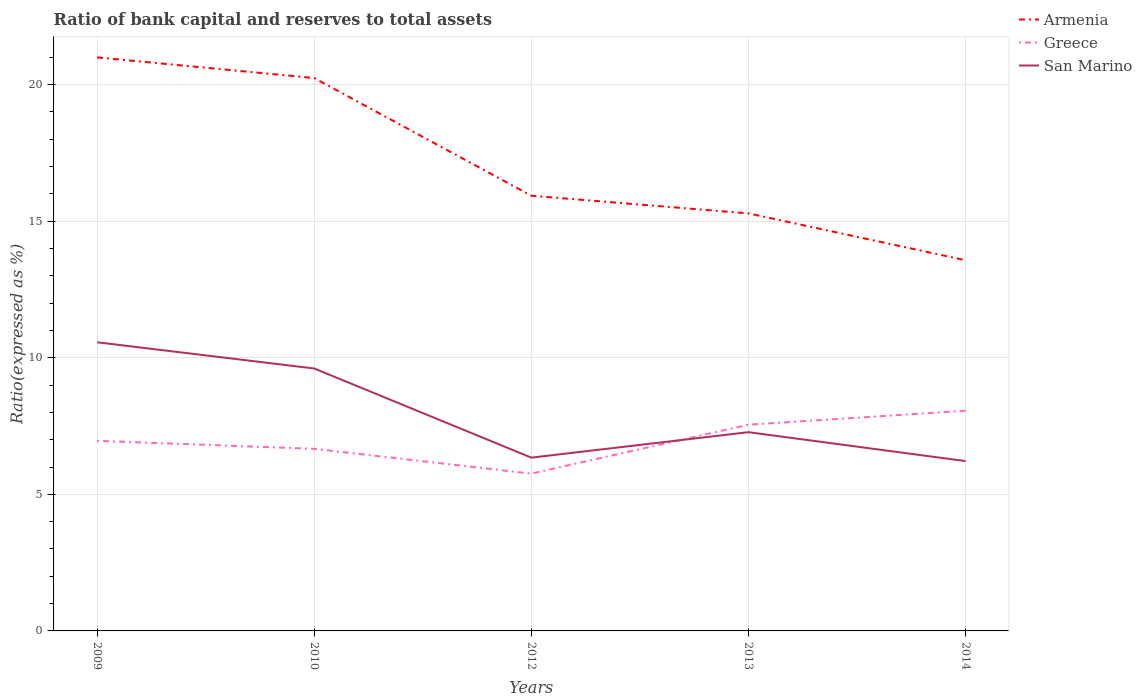Does the line corresponding to San Marino intersect with the line corresponding to Greece?
Keep it short and to the point. Yes. Across all years, what is the maximum ratio of bank capital and reserves to total assets in Armenia?
Keep it short and to the point. 13.57. In which year was the ratio of bank capital and reserves to total assets in Greece maximum?
Offer a very short reply. 2012. What is the total ratio of bank capital and reserves to total assets in San Marino in the graph?
Your answer should be very brief. 4.22. What is the difference between the highest and the second highest ratio of bank capital and reserves to total assets in Greece?
Offer a terse response. 2.3. How many lines are there?
Make the answer very short. 3. What is the difference between two consecutive major ticks on the Y-axis?
Offer a very short reply. 5. Does the graph contain any zero values?
Provide a succinct answer. No. Does the graph contain grids?
Your answer should be very brief. Yes. Where does the legend appear in the graph?
Your answer should be very brief. Top right. How many legend labels are there?
Your response must be concise. 3. What is the title of the graph?
Ensure brevity in your answer.  Ratio of bank capital and reserves to total assets. What is the label or title of the Y-axis?
Your answer should be very brief. Ratio(expressed as %). What is the Ratio(expressed as %) in Armenia in 2009?
Ensure brevity in your answer.  20.99. What is the Ratio(expressed as %) of Greece in 2009?
Your answer should be compact. 6.96. What is the Ratio(expressed as %) of San Marino in 2009?
Your answer should be very brief. 10.57. What is the Ratio(expressed as %) in Armenia in 2010?
Offer a terse response. 20.24. What is the Ratio(expressed as %) in Greece in 2010?
Offer a terse response. 6.66. What is the Ratio(expressed as %) in San Marino in 2010?
Your answer should be very brief. 9.61. What is the Ratio(expressed as %) in Armenia in 2012?
Keep it short and to the point. 15.93. What is the Ratio(expressed as %) in Greece in 2012?
Your answer should be very brief. 5.76. What is the Ratio(expressed as %) of San Marino in 2012?
Your answer should be compact. 6.34. What is the Ratio(expressed as %) in Armenia in 2013?
Offer a terse response. 15.28. What is the Ratio(expressed as %) of Greece in 2013?
Provide a succinct answer. 7.55. What is the Ratio(expressed as %) in San Marino in 2013?
Give a very brief answer. 7.28. What is the Ratio(expressed as %) in Armenia in 2014?
Offer a very short reply. 13.57. What is the Ratio(expressed as %) of Greece in 2014?
Offer a very short reply. 8.06. What is the Ratio(expressed as %) in San Marino in 2014?
Provide a short and direct response. 6.22. Across all years, what is the maximum Ratio(expressed as %) of Armenia?
Make the answer very short. 20.99. Across all years, what is the maximum Ratio(expressed as %) in Greece?
Your response must be concise. 8.06. Across all years, what is the maximum Ratio(expressed as %) of San Marino?
Provide a succinct answer. 10.57. Across all years, what is the minimum Ratio(expressed as %) of Armenia?
Provide a succinct answer. 13.57. Across all years, what is the minimum Ratio(expressed as %) of Greece?
Give a very brief answer. 5.76. Across all years, what is the minimum Ratio(expressed as %) in San Marino?
Provide a short and direct response. 6.22. What is the total Ratio(expressed as %) of Armenia in the graph?
Provide a short and direct response. 86.02. What is the total Ratio(expressed as %) of Greece in the graph?
Ensure brevity in your answer.  34.99. What is the total Ratio(expressed as %) in San Marino in the graph?
Provide a succinct answer. 40.01. What is the difference between the Ratio(expressed as %) of Armenia in 2009 and that in 2010?
Offer a very short reply. 0.76. What is the difference between the Ratio(expressed as %) of Greece in 2009 and that in 2010?
Provide a succinct answer. 0.29. What is the difference between the Ratio(expressed as %) in San Marino in 2009 and that in 2010?
Offer a terse response. 0.96. What is the difference between the Ratio(expressed as %) in Armenia in 2009 and that in 2012?
Your answer should be very brief. 5.06. What is the difference between the Ratio(expressed as %) in Greece in 2009 and that in 2012?
Your answer should be very brief. 1.2. What is the difference between the Ratio(expressed as %) of San Marino in 2009 and that in 2012?
Keep it short and to the point. 4.22. What is the difference between the Ratio(expressed as %) of Armenia in 2009 and that in 2013?
Make the answer very short. 5.71. What is the difference between the Ratio(expressed as %) in Greece in 2009 and that in 2013?
Provide a short and direct response. -0.59. What is the difference between the Ratio(expressed as %) of San Marino in 2009 and that in 2013?
Your response must be concise. 3.29. What is the difference between the Ratio(expressed as %) of Armenia in 2009 and that in 2014?
Offer a terse response. 7.43. What is the difference between the Ratio(expressed as %) of Greece in 2009 and that in 2014?
Ensure brevity in your answer.  -1.1. What is the difference between the Ratio(expressed as %) in San Marino in 2009 and that in 2014?
Your answer should be compact. 4.35. What is the difference between the Ratio(expressed as %) in Armenia in 2010 and that in 2012?
Your answer should be compact. 4.31. What is the difference between the Ratio(expressed as %) of Greece in 2010 and that in 2012?
Ensure brevity in your answer.  0.91. What is the difference between the Ratio(expressed as %) of San Marino in 2010 and that in 2012?
Provide a succinct answer. 3.26. What is the difference between the Ratio(expressed as %) of Armenia in 2010 and that in 2013?
Offer a terse response. 4.95. What is the difference between the Ratio(expressed as %) in Greece in 2010 and that in 2013?
Give a very brief answer. -0.88. What is the difference between the Ratio(expressed as %) in San Marino in 2010 and that in 2013?
Offer a terse response. 2.33. What is the difference between the Ratio(expressed as %) of Armenia in 2010 and that in 2014?
Give a very brief answer. 6.67. What is the difference between the Ratio(expressed as %) in Greece in 2010 and that in 2014?
Ensure brevity in your answer.  -1.4. What is the difference between the Ratio(expressed as %) of San Marino in 2010 and that in 2014?
Keep it short and to the point. 3.39. What is the difference between the Ratio(expressed as %) in Armenia in 2012 and that in 2013?
Offer a very short reply. 0.65. What is the difference between the Ratio(expressed as %) in Greece in 2012 and that in 2013?
Your answer should be compact. -1.79. What is the difference between the Ratio(expressed as %) of San Marino in 2012 and that in 2013?
Offer a terse response. -0.93. What is the difference between the Ratio(expressed as %) of Armenia in 2012 and that in 2014?
Provide a short and direct response. 2.36. What is the difference between the Ratio(expressed as %) of Greece in 2012 and that in 2014?
Make the answer very short. -2.3. What is the difference between the Ratio(expressed as %) of San Marino in 2012 and that in 2014?
Provide a succinct answer. 0.13. What is the difference between the Ratio(expressed as %) of Armenia in 2013 and that in 2014?
Your answer should be compact. 1.71. What is the difference between the Ratio(expressed as %) of Greece in 2013 and that in 2014?
Your answer should be compact. -0.51. What is the difference between the Ratio(expressed as %) in San Marino in 2013 and that in 2014?
Your response must be concise. 1.06. What is the difference between the Ratio(expressed as %) in Armenia in 2009 and the Ratio(expressed as %) in Greece in 2010?
Your response must be concise. 14.33. What is the difference between the Ratio(expressed as %) of Armenia in 2009 and the Ratio(expressed as %) of San Marino in 2010?
Your answer should be very brief. 11.39. What is the difference between the Ratio(expressed as %) in Greece in 2009 and the Ratio(expressed as %) in San Marino in 2010?
Provide a succinct answer. -2.65. What is the difference between the Ratio(expressed as %) of Armenia in 2009 and the Ratio(expressed as %) of Greece in 2012?
Keep it short and to the point. 15.24. What is the difference between the Ratio(expressed as %) in Armenia in 2009 and the Ratio(expressed as %) in San Marino in 2012?
Provide a succinct answer. 14.65. What is the difference between the Ratio(expressed as %) of Greece in 2009 and the Ratio(expressed as %) of San Marino in 2012?
Give a very brief answer. 0.62. What is the difference between the Ratio(expressed as %) of Armenia in 2009 and the Ratio(expressed as %) of Greece in 2013?
Make the answer very short. 13.45. What is the difference between the Ratio(expressed as %) of Armenia in 2009 and the Ratio(expressed as %) of San Marino in 2013?
Ensure brevity in your answer.  13.72. What is the difference between the Ratio(expressed as %) of Greece in 2009 and the Ratio(expressed as %) of San Marino in 2013?
Provide a succinct answer. -0.32. What is the difference between the Ratio(expressed as %) of Armenia in 2009 and the Ratio(expressed as %) of Greece in 2014?
Give a very brief answer. 12.93. What is the difference between the Ratio(expressed as %) in Armenia in 2009 and the Ratio(expressed as %) in San Marino in 2014?
Provide a succinct answer. 14.78. What is the difference between the Ratio(expressed as %) in Greece in 2009 and the Ratio(expressed as %) in San Marino in 2014?
Provide a short and direct response. 0.74. What is the difference between the Ratio(expressed as %) in Armenia in 2010 and the Ratio(expressed as %) in Greece in 2012?
Your response must be concise. 14.48. What is the difference between the Ratio(expressed as %) in Armenia in 2010 and the Ratio(expressed as %) in San Marino in 2012?
Offer a very short reply. 13.89. What is the difference between the Ratio(expressed as %) in Greece in 2010 and the Ratio(expressed as %) in San Marino in 2012?
Your response must be concise. 0.32. What is the difference between the Ratio(expressed as %) in Armenia in 2010 and the Ratio(expressed as %) in Greece in 2013?
Keep it short and to the point. 12.69. What is the difference between the Ratio(expressed as %) in Armenia in 2010 and the Ratio(expressed as %) in San Marino in 2013?
Offer a terse response. 12.96. What is the difference between the Ratio(expressed as %) in Greece in 2010 and the Ratio(expressed as %) in San Marino in 2013?
Provide a short and direct response. -0.61. What is the difference between the Ratio(expressed as %) in Armenia in 2010 and the Ratio(expressed as %) in Greece in 2014?
Offer a very short reply. 12.18. What is the difference between the Ratio(expressed as %) of Armenia in 2010 and the Ratio(expressed as %) of San Marino in 2014?
Offer a terse response. 14.02. What is the difference between the Ratio(expressed as %) of Greece in 2010 and the Ratio(expressed as %) of San Marino in 2014?
Provide a short and direct response. 0.45. What is the difference between the Ratio(expressed as %) of Armenia in 2012 and the Ratio(expressed as %) of Greece in 2013?
Offer a terse response. 8.38. What is the difference between the Ratio(expressed as %) in Armenia in 2012 and the Ratio(expressed as %) in San Marino in 2013?
Make the answer very short. 8.66. What is the difference between the Ratio(expressed as %) in Greece in 2012 and the Ratio(expressed as %) in San Marino in 2013?
Offer a very short reply. -1.52. What is the difference between the Ratio(expressed as %) in Armenia in 2012 and the Ratio(expressed as %) in Greece in 2014?
Keep it short and to the point. 7.87. What is the difference between the Ratio(expressed as %) of Armenia in 2012 and the Ratio(expressed as %) of San Marino in 2014?
Give a very brief answer. 9.71. What is the difference between the Ratio(expressed as %) of Greece in 2012 and the Ratio(expressed as %) of San Marino in 2014?
Provide a succinct answer. -0.46. What is the difference between the Ratio(expressed as %) of Armenia in 2013 and the Ratio(expressed as %) of Greece in 2014?
Keep it short and to the point. 7.22. What is the difference between the Ratio(expressed as %) of Armenia in 2013 and the Ratio(expressed as %) of San Marino in 2014?
Keep it short and to the point. 9.07. What is the difference between the Ratio(expressed as %) in Greece in 2013 and the Ratio(expressed as %) in San Marino in 2014?
Your answer should be compact. 1.33. What is the average Ratio(expressed as %) of Armenia per year?
Provide a succinct answer. 17.2. What is the average Ratio(expressed as %) of Greece per year?
Make the answer very short. 7. What is the average Ratio(expressed as %) of San Marino per year?
Make the answer very short. 8. In the year 2009, what is the difference between the Ratio(expressed as %) in Armenia and Ratio(expressed as %) in Greece?
Your response must be concise. 14.04. In the year 2009, what is the difference between the Ratio(expressed as %) of Armenia and Ratio(expressed as %) of San Marino?
Your response must be concise. 10.43. In the year 2009, what is the difference between the Ratio(expressed as %) in Greece and Ratio(expressed as %) in San Marino?
Your response must be concise. -3.61. In the year 2010, what is the difference between the Ratio(expressed as %) in Armenia and Ratio(expressed as %) in Greece?
Your response must be concise. 13.57. In the year 2010, what is the difference between the Ratio(expressed as %) in Armenia and Ratio(expressed as %) in San Marino?
Offer a very short reply. 10.63. In the year 2010, what is the difference between the Ratio(expressed as %) of Greece and Ratio(expressed as %) of San Marino?
Provide a succinct answer. -2.94. In the year 2012, what is the difference between the Ratio(expressed as %) of Armenia and Ratio(expressed as %) of Greece?
Provide a succinct answer. 10.17. In the year 2012, what is the difference between the Ratio(expressed as %) of Armenia and Ratio(expressed as %) of San Marino?
Provide a short and direct response. 9.59. In the year 2012, what is the difference between the Ratio(expressed as %) of Greece and Ratio(expressed as %) of San Marino?
Provide a succinct answer. -0.59. In the year 2013, what is the difference between the Ratio(expressed as %) in Armenia and Ratio(expressed as %) in Greece?
Make the answer very short. 7.74. In the year 2013, what is the difference between the Ratio(expressed as %) in Armenia and Ratio(expressed as %) in San Marino?
Your response must be concise. 8.01. In the year 2013, what is the difference between the Ratio(expressed as %) in Greece and Ratio(expressed as %) in San Marino?
Ensure brevity in your answer.  0.27. In the year 2014, what is the difference between the Ratio(expressed as %) of Armenia and Ratio(expressed as %) of Greece?
Your response must be concise. 5.51. In the year 2014, what is the difference between the Ratio(expressed as %) of Armenia and Ratio(expressed as %) of San Marino?
Give a very brief answer. 7.35. In the year 2014, what is the difference between the Ratio(expressed as %) in Greece and Ratio(expressed as %) in San Marino?
Make the answer very short. 1.84. What is the ratio of the Ratio(expressed as %) in Armenia in 2009 to that in 2010?
Your answer should be very brief. 1.04. What is the ratio of the Ratio(expressed as %) of Greece in 2009 to that in 2010?
Your answer should be very brief. 1.04. What is the ratio of the Ratio(expressed as %) of San Marino in 2009 to that in 2010?
Your response must be concise. 1.1. What is the ratio of the Ratio(expressed as %) in Armenia in 2009 to that in 2012?
Ensure brevity in your answer.  1.32. What is the ratio of the Ratio(expressed as %) in Greece in 2009 to that in 2012?
Offer a very short reply. 1.21. What is the ratio of the Ratio(expressed as %) in San Marino in 2009 to that in 2012?
Offer a terse response. 1.67. What is the ratio of the Ratio(expressed as %) of Armenia in 2009 to that in 2013?
Provide a short and direct response. 1.37. What is the ratio of the Ratio(expressed as %) in Greece in 2009 to that in 2013?
Provide a short and direct response. 0.92. What is the ratio of the Ratio(expressed as %) of San Marino in 2009 to that in 2013?
Your answer should be very brief. 1.45. What is the ratio of the Ratio(expressed as %) in Armenia in 2009 to that in 2014?
Offer a very short reply. 1.55. What is the ratio of the Ratio(expressed as %) in Greece in 2009 to that in 2014?
Offer a terse response. 0.86. What is the ratio of the Ratio(expressed as %) in San Marino in 2009 to that in 2014?
Offer a terse response. 1.7. What is the ratio of the Ratio(expressed as %) of Armenia in 2010 to that in 2012?
Provide a succinct answer. 1.27. What is the ratio of the Ratio(expressed as %) of Greece in 2010 to that in 2012?
Provide a short and direct response. 1.16. What is the ratio of the Ratio(expressed as %) in San Marino in 2010 to that in 2012?
Your answer should be very brief. 1.51. What is the ratio of the Ratio(expressed as %) of Armenia in 2010 to that in 2013?
Your answer should be compact. 1.32. What is the ratio of the Ratio(expressed as %) of Greece in 2010 to that in 2013?
Your response must be concise. 0.88. What is the ratio of the Ratio(expressed as %) of San Marino in 2010 to that in 2013?
Give a very brief answer. 1.32. What is the ratio of the Ratio(expressed as %) of Armenia in 2010 to that in 2014?
Offer a very short reply. 1.49. What is the ratio of the Ratio(expressed as %) in Greece in 2010 to that in 2014?
Your answer should be very brief. 0.83. What is the ratio of the Ratio(expressed as %) in San Marino in 2010 to that in 2014?
Your answer should be compact. 1.55. What is the ratio of the Ratio(expressed as %) in Armenia in 2012 to that in 2013?
Keep it short and to the point. 1.04. What is the ratio of the Ratio(expressed as %) of Greece in 2012 to that in 2013?
Make the answer very short. 0.76. What is the ratio of the Ratio(expressed as %) of San Marino in 2012 to that in 2013?
Offer a very short reply. 0.87. What is the ratio of the Ratio(expressed as %) in Armenia in 2012 to that in 2014?
Ensure brevity in your answer.  1.17. What is the ratio of the Ratio(expressed as %) in Greece in 2012 to that in 2014?
Provide a succinct answer. 0.71. What is the ratio of the Ratio(expressed as %) of San Marino in 2012 to that in 2014?
Ensure brevity in your answer.  1.02. What is the ratio of the Ratio(expressed as %) in Armenia in 2013 to that in 2014?
Offer a terse response. 1.13. What is the ratio of the Ratio(expressed as %) in Greece in 2013 to that in 2014?
Make the answer very short. 0.94. What is the ratio of the Ratio(expressed as %) in San Marino in 2013 to that in 2014?
Your answer should be compact. 1.17. What is the difference between the highest and the second highest Ratio(expressed as %) of Armenia?
Provide a succinct answer. 0.76. What is the difference between the highest and the second highest Ratio(expressed as %) of Greece?
Keep it short and to the point. 0.51. What is the difference between the highest and the second highest Ratio(expressed as %) of San Marino?
Provide a succinct answer. 0.96. What is the difference between the highest and the lowest Ratio(expressed as %) of Armenia?
Ensure brevity in your answer.  7.43. What is the difference between the highest and the lowest Ratio(expressed as %) in Greece?
Your response must be concise. 2.3. What is the difference between the highest and the lowest Ratio(expressed as %) in San Marino?
Your response must be concise. 4.35. 